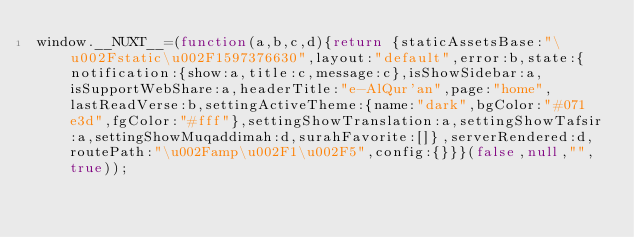Convert code to text. <code><loc_0><loc_0><loc_500><loc_500><_JavaScript_>window.__NUXT__=(function(a,b,c,d){return {staticAssetsBase:"\u002Fstatic\u002F1597376630",layout:"default",error:b,state:{notification:{show:a,title:c,message:c},isShowSidebar:a,isSupportWebShare:a,headerTitle:"e-AlQur'an",page:"home",lastReadVerse:b,settingActiveTheme:{name:"dark",bgColor:"#071e3d",fgColor:"#fff"},settingShowTranslation:a,settingShowTafsir:a,settingShowMuqaddimah:d,surahFavorite:[]},serverRendered:d,routePath:"\u002Famp\u002F1\u002F5",config:{}}}(false,null,"",true));</code> 